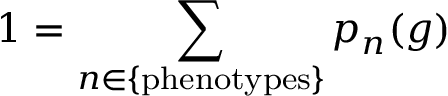<formula> <loc_0><loc_0><loc_500><loc_500>1 = \sum _ { n \in \{ p h e n o t y p e s \} } p _ { n } ( g )</formula> 